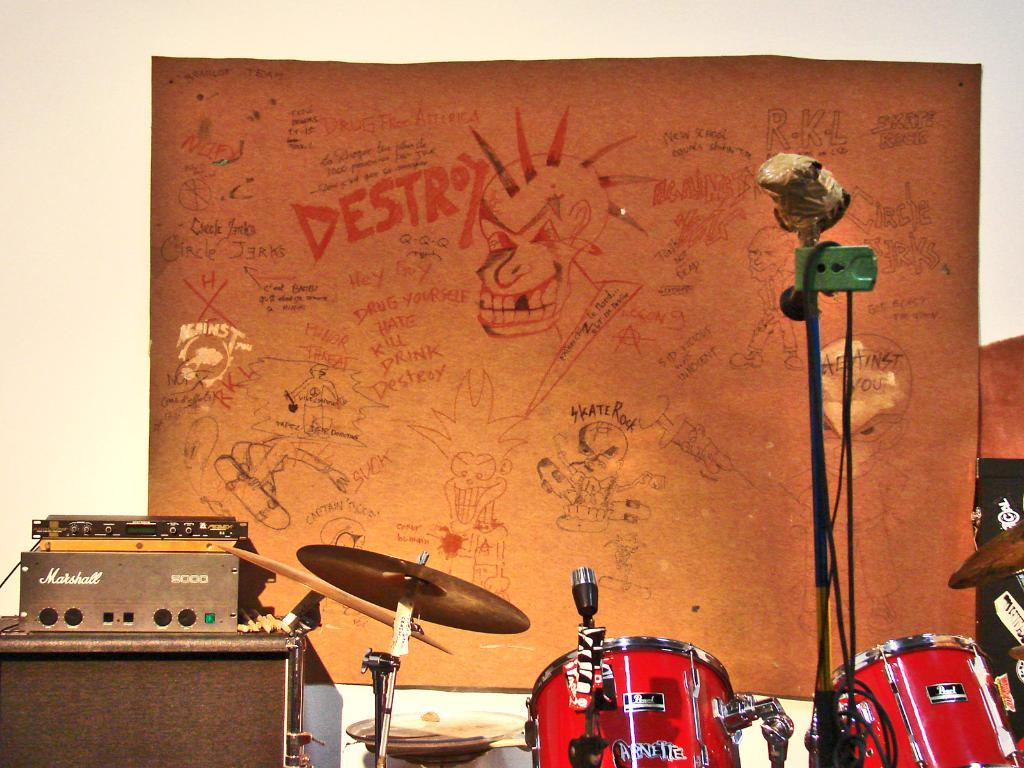<image>
Present a compact description of the photo's key features. Instruments sitting in front of a cork board with the word DESTROY written near the top. 